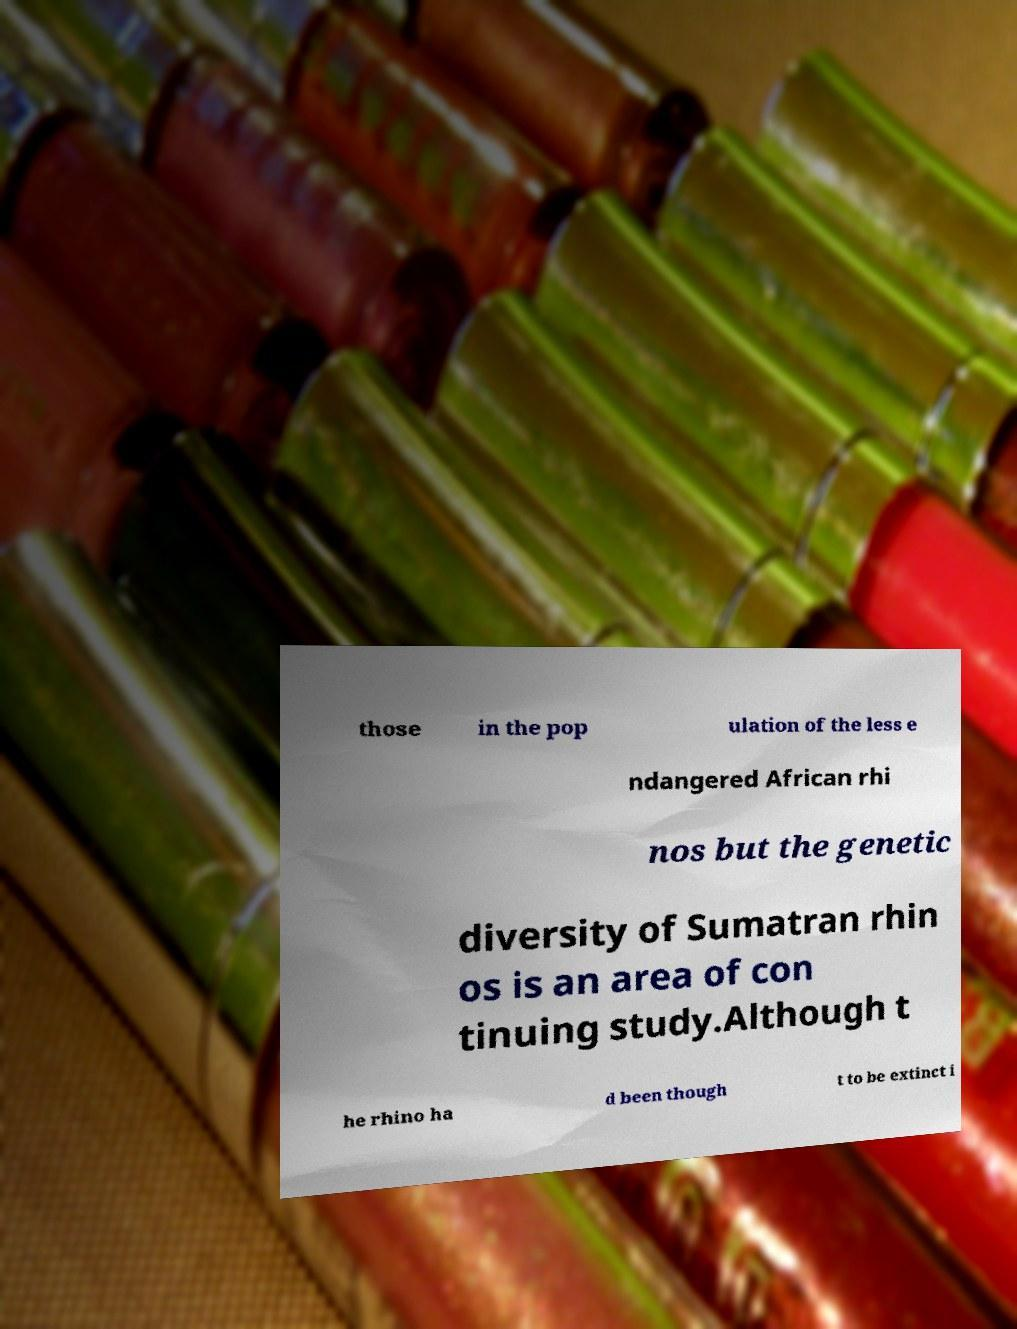Please read and relay the text visible in this image. What does it say? those in the pop ulation of the less e ndangered African rhi nos but the genetic diversity of Sumatran rhin os is an area of con tinuing study.Although t he rhino ha d been though t to be extinct i 